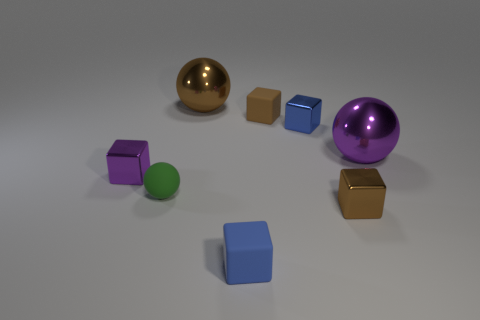Which objects stand out the most in this composition, and why? The large purple sphere stands out due to its size and shiny surface. Its position, slightly separated from the rest, along with its size and color, draws the viewer's attention. What mood or atmosphere do you think these objects convey? The image has a very neutral and calm atmosphere. The soft lighting and simple background don't evoke a strong emotional response, which allows the focus to remain on the shapes and colors of the objects. 